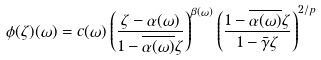<formula> <loc_0><loc_0><loc_500><loc_500>\phi ( \zeta ) ( \omega ) = c ( \omega ) \left ( \frac { \zeta - \alpha ( \omega ) } { 1 - \overline { \alpha ( \omega ) } \zeta } \right ) ^ { \beta ( \omega ) } \left ( \frac { 1 - \overline { \alpha ( \omega ) } \zeta } { 1 - \bar { \gamma } \zeta } \right ) ^ { 2 / p }</formula> 